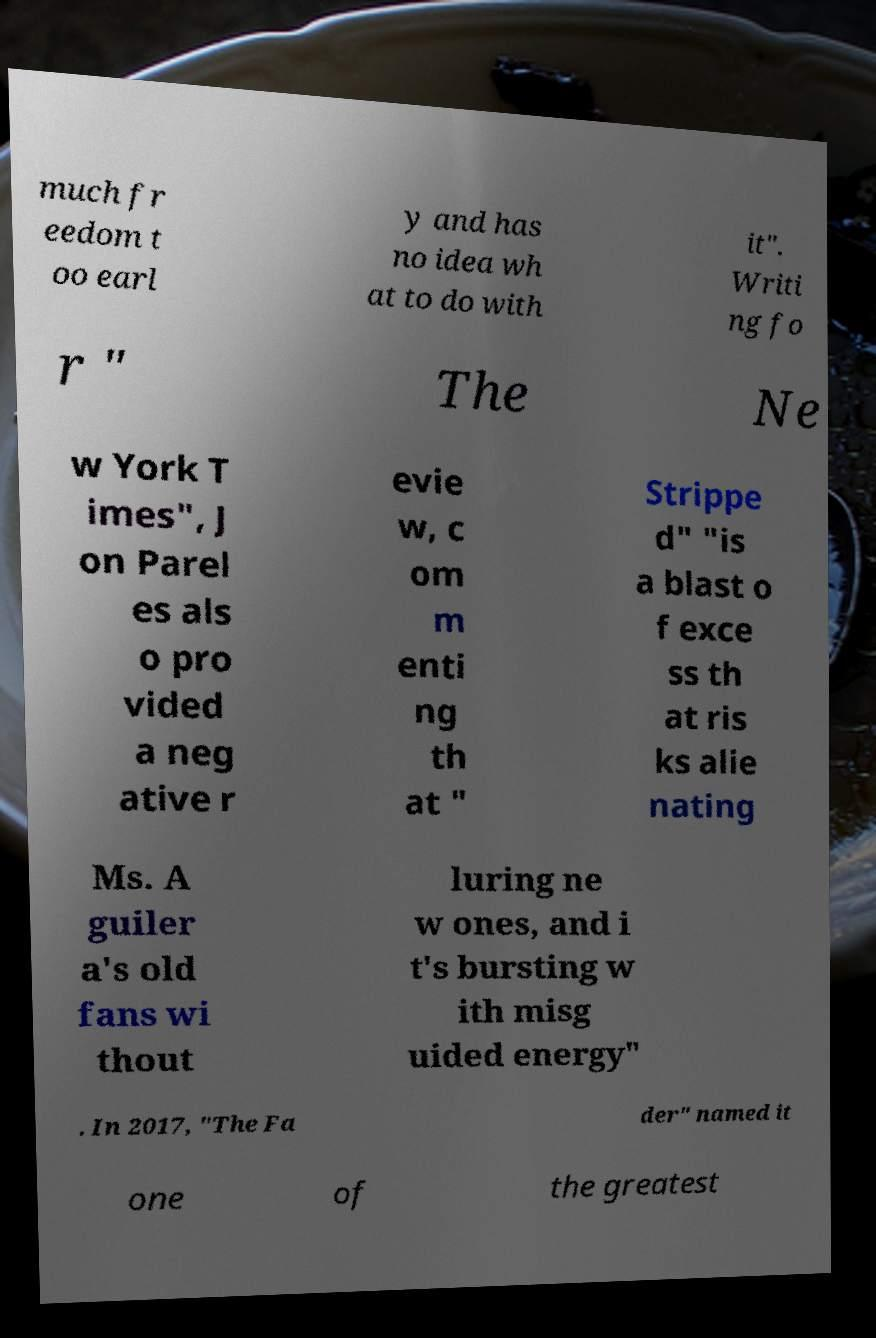Can you accurately transcribe the text from the provided image for me? much fr eedom t oo earl y and has no idea wh at to do with it". Writi ng fo r " The Ne w York T imes", J on Parel es als o pro vided a neg ative r evie w, c om m enti ng th at " Strippe d" "is a blast o f exce ss th at ris ks alie nating Ms. A guiler a's old fans wi thout luring ne w ones, and i t's bursting w ith misg uided energy" . In 2017, "The Fa der" named it one of the greatest 